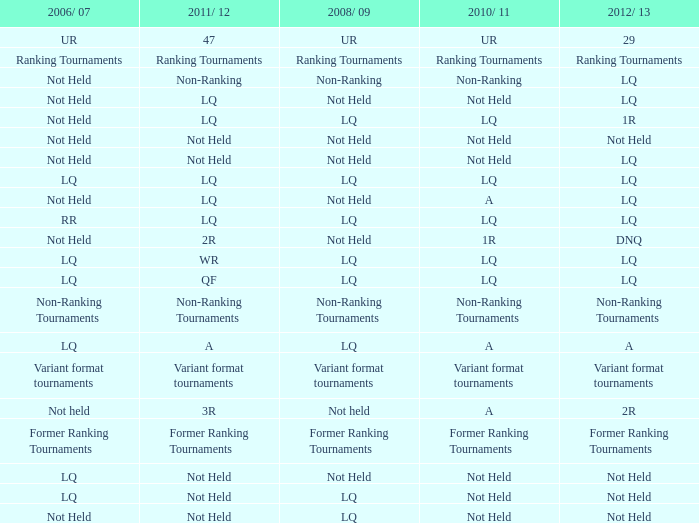What is 2006/07, when 2008/09 is LQ, and when 2010/11 is Not Held? LQ, Not Held. 